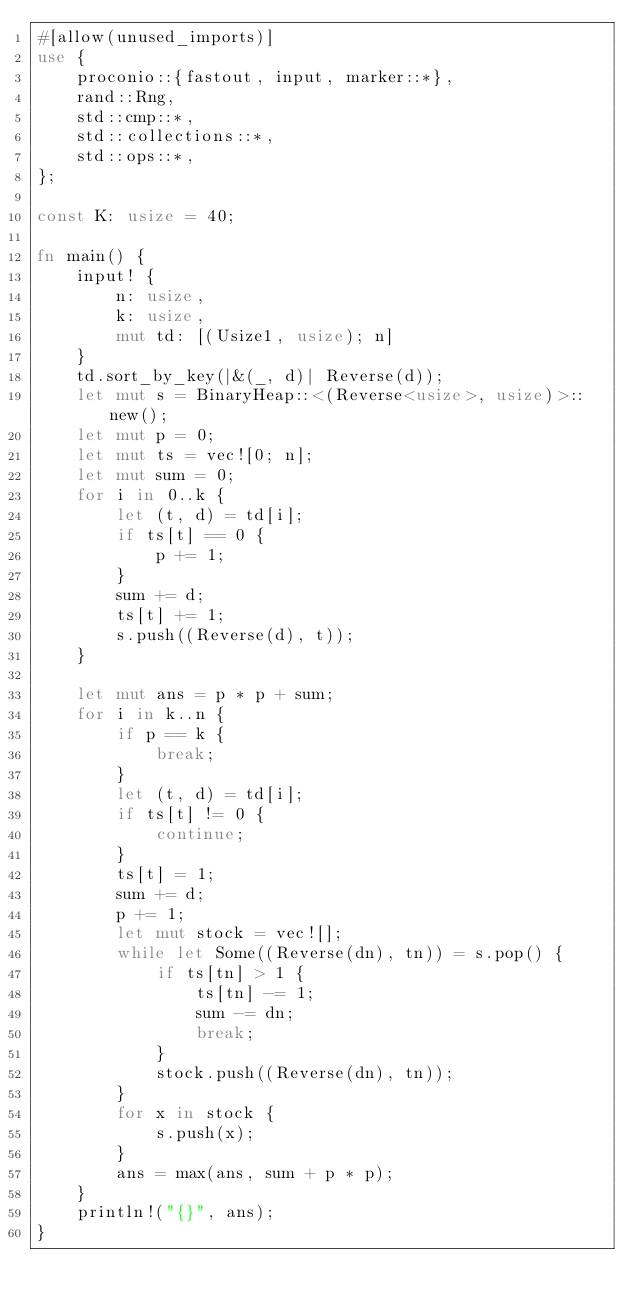Convert code to text. <code><loc_0><loc_0><loc_500><loc_500><_Rust_>#[allow(unused_imports)]
use {
    proconio::{fastout, input, marker::*},
    rand::Rng,
    std::cmp::*,
    std::collections::*,
    std::ops::*,
};

const K: usize = 40;

fn main() {
    input! {
        n: usize,
        k: usize,
        mut td: [(Usize1, usize); n]
    }
    td.sort_by_key(|&(_, d)| Reverse(d));
    let mut s = BinaryHeap::<(Reverse<usize>, usize)>::new();
    let mut p = 0;
    let mut ts = vec![0; n];
    let mut sum = 0;
    for i in 0..k {
        let (t, d) = td[i];
        if ts[t] == 0 {
            p += 1;
        }
        sum += d;
        ts[t] += 1;
        s.push((Reverse(d), t));
    }

    let mut ans = p * p + sum;
    for i in k..n {
        if p == k {
            break;
        }
        let (t, d) = td[i];
        if ts[t] != 0 {
            continue;
        }
        ts[t] = 1;
        sum += d;
        p += 1;
        let mut stock = vec![];
        while let Some((Reverse(dn), tn)) = s.pop() {
            if ts[tn] > 1 {
                ts[tn] -= 1;
                sum -= dn;
                break;
            }
            stock.push((Reverse(dn), tn));
        }
        for x in stock {
            s.push(x);
        }
        ans = max(ans, sum + p * p);
    }
    println!("{}", ans);
}
</code> 